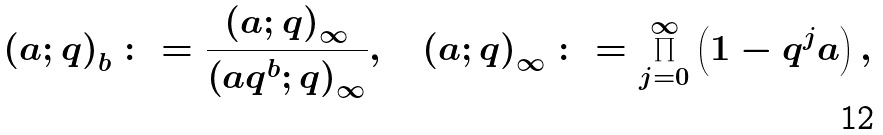Convert formula to latex. <formula><loc_0><loc_0><loc_500><loc_500>\left ( a ; q \right ) _ { b } \colon = \frac { \left ( a ; q \right ) _ { \infty } } { \left ( a q ^ { b } ; q \right ) _ { \infty } } , \quad \left ( a ; q \right ) _ { \infty } \colon = \prod _ { j = 0 } ^ { \infty } \left ( 1 - q ^ { j } a \right ) ,</formula> 